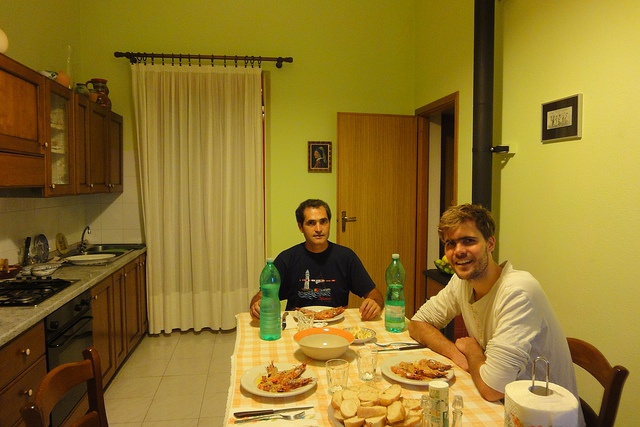Describe the objects in this image and their specific colors. I can see dining table in olive, khaki, tan, and orange tones, people in olive, tan, and maroon tones, people in olive, black, brown, and maroon tones, chair in olive, black, and maroon tones, and chair in olive, maroon, and black tones in this image. 